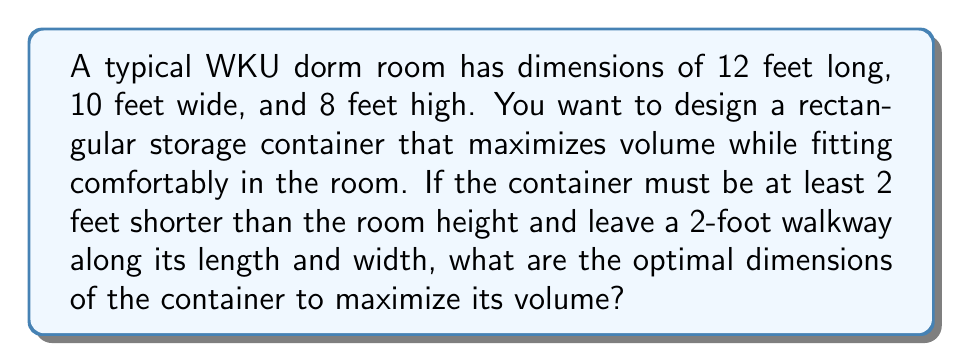Provide a solution to this math problem. Let's approach this step-by-step:

1) First, let's define our variables:
   Let $x$ = length of the container
   Let $y$ = width of the container
   Let $z$ = height of the container

2) Given the room dimensions and constraints:
   $x \leq 12 - 2 = 10$ feet (leaving 2-foot walkway)
   $y \leq 10 - 2 = 8$ feet (leaving 2-foot walkway)
   $z \leq 8 - 2 = 6$ feet (at least 2 feet shorter than room height)

3) The volume of the container is given by:
   $V = xyz$

4) To maximize volume, we want to use the maximum available dimensions:
   $x = 10$, $y = 8$, $z = 6$

5) Therefore, the maximum volume is:
   $V_{max} = 10 \times 8 \times 6 = 480$ cubic feet

6) The optimal dimensions are:
   Length: 10 feet
   Width: 8 feet
   Height: 6 feet

This configuration maximizes the storage volume while adhering to the given constraints.
Answer: Length: 10 ft, Width: 8 ft, Height: 6 ft 